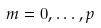Convert formula to latex. <formula><loc_0><loc_0><loc_500><loc_500>m = 0 , \dots , p</formula> 